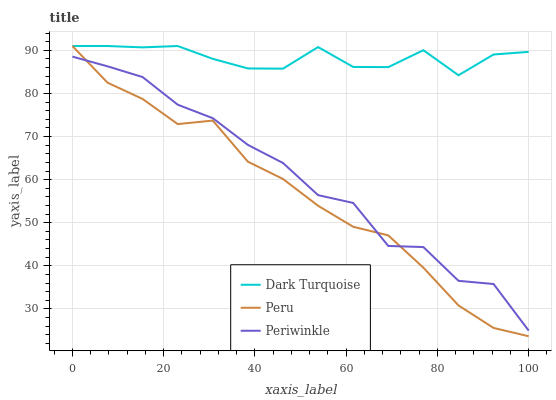Does Periwinkle have the minimum area under the curve?
Answer yes or no. No. Does Periwinkle have the maximum area under the curve?
Answer yes or no. No. Is Periwinkle the smoothest?
Answer yes or no. No. Is Peru the roughest?
Answer yes or no. No. Does Periwinkle have the lowest value?
Answer yes or no. No. Does Periwinkle have the highest value?
Answer yes or no. No. Is Periwinkle less than Dark Turquoise?
Answer yes or no. Yes. Is Dark Turquoise greater than Periwinkle?
Answer yes or no. Yes. Does Periwinkle intersect Dark Turquoise?
Answer yes or no. No. 